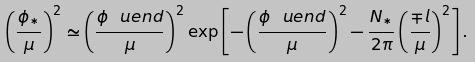Convert formula to latex. <formula><loc_0><loc_0><loc_500><loc_500>\left ( \frac { \phi _ { * } } { \mu } \right ) ^ { 2 } \simeq \left ( \frac { \phi _ { \ } u e n d } { \mu } \right ) ^ { 2 } \exp \left [ - \left ( \frac { \phi _ { \ } u e n d } { \mu } \right ) ^ { 2 } - \frac { N _ { * } } { 2 \pi } \left ( \frac { \mp l } { \mu } \right ) ^ { 2 } \right ] .</formula> 